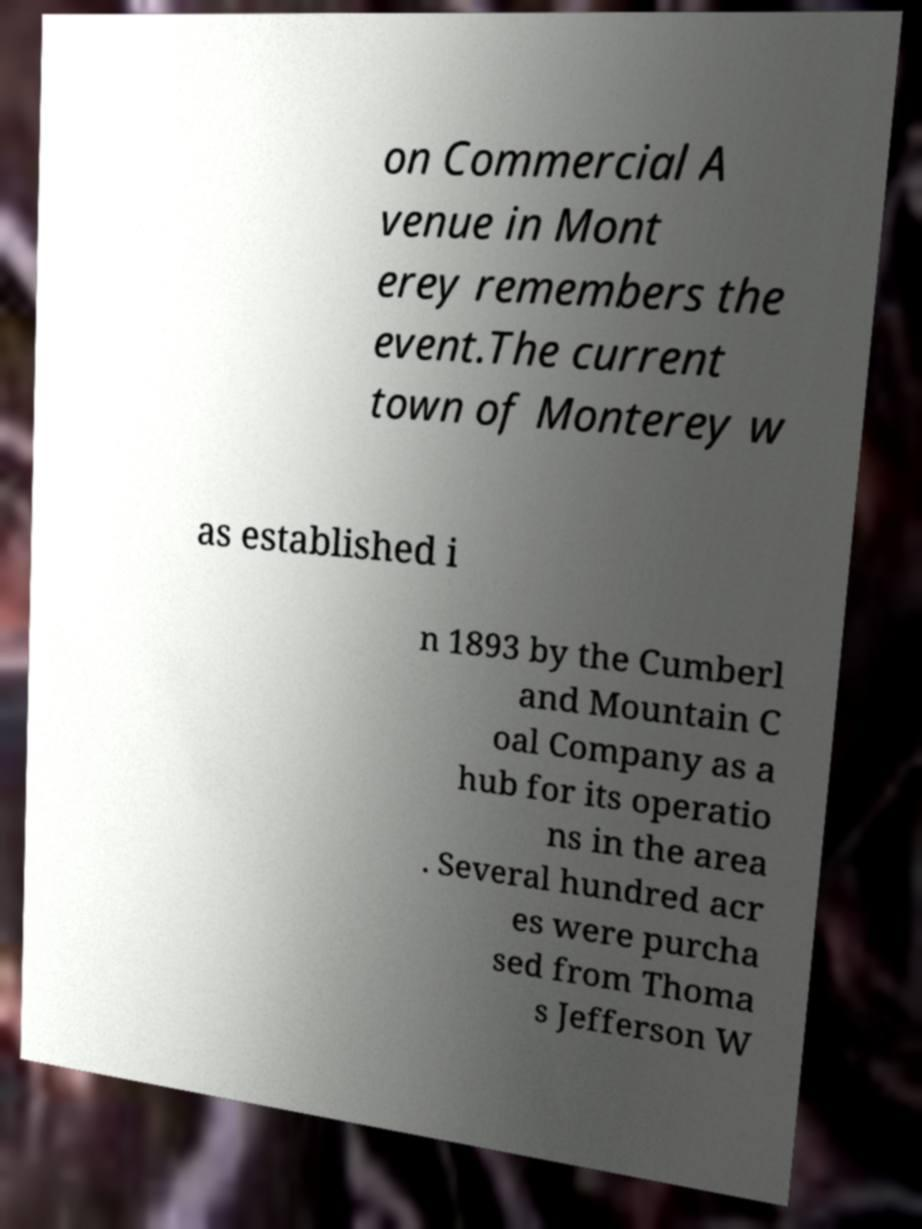Please identify and transcribe the text found in this image. on Commercial A venue in Mont erey remembers the event.The current town of Monterey w as established i n 1893 by the Cumberl and Mountain C oal Company as a hub for its operatio ns in the area . Several hundred acr es were purcha sed from Thoma s Jefferson W 